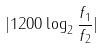Convert formula to latex. <formula><loc_0><loc_0><loc_500><loc_500>| 1 2 0 0 \log _ { 2 } \frac { f _ { 1 } } { f _ { 2 } } |</formula> 